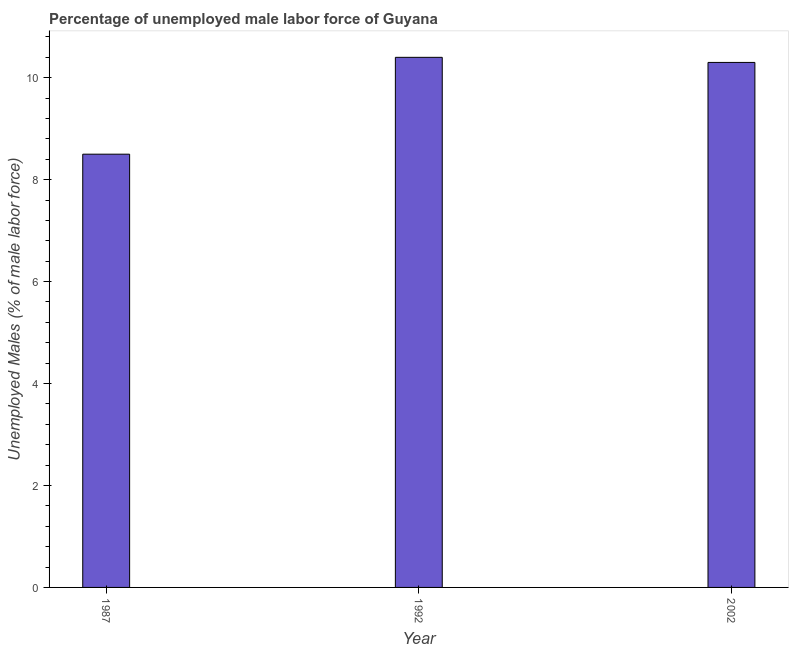Does the graph contain any zero values?
Give a very brief answer. No. Does the graph contain grids?
Your answer should be compact. No. What is the title of the graph?
Keep it short and to the point. Percentage of unemployed male labor force of Guyana. What is the label or title of the X-axis?
Your response must be concise. Year. What is the label or title of the Y-axis?
Provide a succinct answer. Unemployed Males (% of male labor force). What is the total unemployed male labour force in 1992?
Your answer should be compact. 10.4. Across all years, what is the maximum total unemployed male labour force?
Make the answer very short. 10.4. Across all years, what is the minimum total unemployed male labour force?
Keep it short and to the point. 8.5. What is the sum of the total unemployed male labour force?
Your answer should be very brief. 29.2. What is the difference between the total unemployed male labour force in 1987 and 2002?
Your answer should be very brief. -1.8. What is the average total unemployed male labour force per year?
Provide a succinct answer. 9.73. What is the median total unemployed male labour force?
Keep it short and to the point. 10.3. In how many years, is the total unemployed male labour force greater than 2.4 %?
Make the answer very short. 3. Do a majority of the years between 2002 and 1992 (inclusive) have total unemployed male labour force greater than 8.8 %?
Ensure brevity in your answer.  No. What is the ratio of the total unemployed male labour force in 1987 to that in 1992?
Give a very brief answer. 0.82. Is the total unemployed male labour force in 1987 less than that in 2002?
Provide a short and direct response. Yes. Is the sum of the total unemployed male labour force in 1987 and 1992 greater than the maximum total unemployed male labour force across all years?
Your response must be concise. Yes. What is the difference between the highest and the lowest total unemployed male labour force?
Offer a very short reply. 1.9. How many bars are there?
Offer a terse response. 3. How many years are there in the graph?
Provide a short and direct response. 3. What is the difference between two consecutive major ticks on the Y-axis?
Your response must be concise. 2. Are the values on the major ticks of Y-axis written in scientific E-notation?
Give a very brief answer. No. What is the Unemployed Males (% of male labor force) of 1992?
Ensure brevity in your answer.  10.4. What is the Unemployed Males (% of male labor force) of 2002?
Offer a very short reply. 10.3. What is the difference between the Unemployed Males (% of male labor force) in 1992 and 2002?
Your response must be concise. 0.1. What is the ratio of the Unemployed Males (% of male labor force) in 1987 to that in 1992?
Keep it short and to the point. 0.82. What is the ratio of the Unemployed Males (% of male labor force) in 1987 to that in 2002?
Ensure brevity in your answer.  0.82. What is the ratio of the Unemployed Males (% of male labor force) in 1992 to that in 2002?
Give a very brief answer. 1.01. 